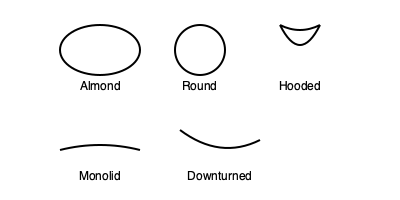Which eye shape would likely show the most dramatic effect when wearing bright blue colored contact lenses? To determine which eye shape would show the most dramatic effect with bright blue colored contact lenses, we need to consider the visibility of the iris in each eye shape:

1. Almond eyes: These have a visible iris but with some coverage by the eyelids.
2. Round eyes: These have the most visible iris area among all shapes.
3. Hooded eyes: The eyelid covers part of the iris, reducing visibility.
4. Monolid eyes: Similar to almond eyes, but with less visible iris area due to the absence of a visible crease.
5. Downturned eyes: These have a visible iris, but the outer corners tilt downward.

The most dramatic effect would be achieved when the colored lens is most visible. Round eyes have the largest exposed iris area, allowing for maximum visibility of the colored lens. This increased visibility would make the bright blue color more noticeable and striking.

In contrast, hooded eyes would show the least dramatic effect as part of the iris is covered by the eyelid, reducing the visible area of the colored lens.
Answer: Round eyes 